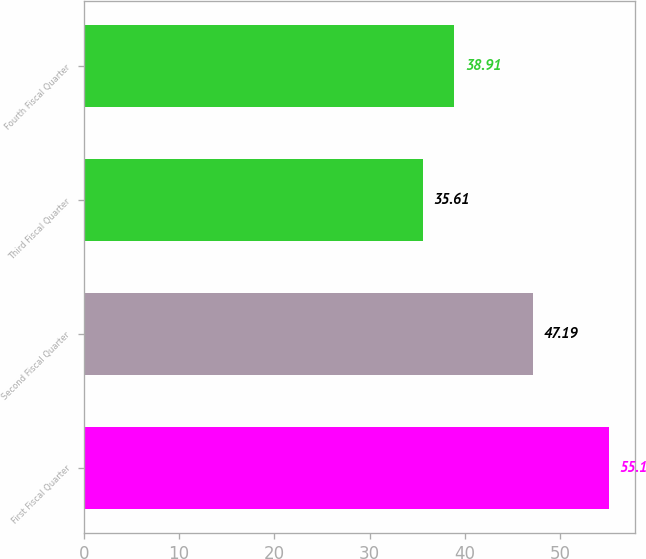<chart> <loc_0><loc_0><loc_500><loc_500><bar_chart><fcel>First Fiscal Quarter<fcel>Second Fiscal Quarter<fcel>Third Fiscal Quarter<fcel>Fourth Fiscal Quarter<nl><fcel>55.1<fcel>47.19<fcel>35.61<fcel>38.91<nl></chart> 